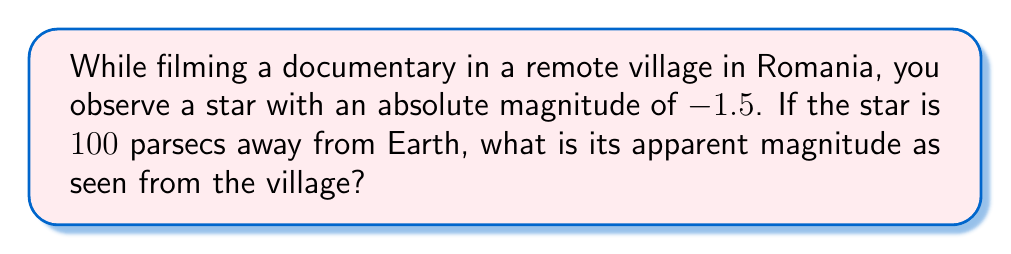Give your solution to this math problem. To solve this problem, we need to use the distance modulus formula, which relates absolute magnitude, apparent magnitude, and distance:

$$ m - M = 5 \log_{10}\left(\frac{d}{10\text{ pc}}\right) $$

Where:
- $m$ is the apparent magnitude (what we're solving for)
- $M$ is the absolute magnitude (given as -1.5)
- $d$ is the distance in parsecs (given as 100 pc)

Let's solve this step-by-step:

1) Insert the known values into the formula:

   $$ m - (-1.5) = 5 \log_{10}\left(\frac{100\text{ pc}}{10\text{ pc}}\right) $$

2) Simplify the right side:

   $$ m + 1.5 = 5 \log_{10}(10) $$

3) Calculate $\log_{10}(10)$, which equals 1:

   $$ m + 1.5 = 5 \cdot 1 = 5 $$

4) Solve for $m$:

   $$ m = 5 - 1.5 = 3.5 $$

Therefore, the apparent magnitude of the star as seen from the Romanian village is 3.5.
Answer: 3.5 